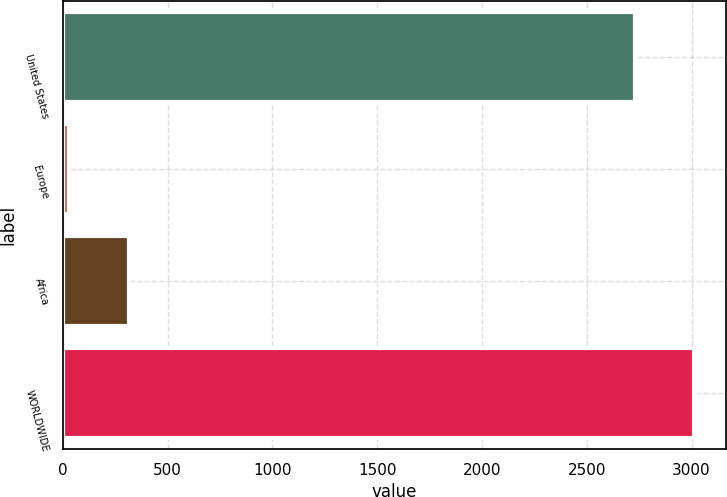<chart> <loc_0><loc_0><loc_500><loc_500><bar_chart><fcel>United States<fcel>Europe<fcel>Africa<fcel>WORLDWIDE<nl><fcel>2729<fcel>31<fcel>313.9<fcel>3011.9<nl></chart> 